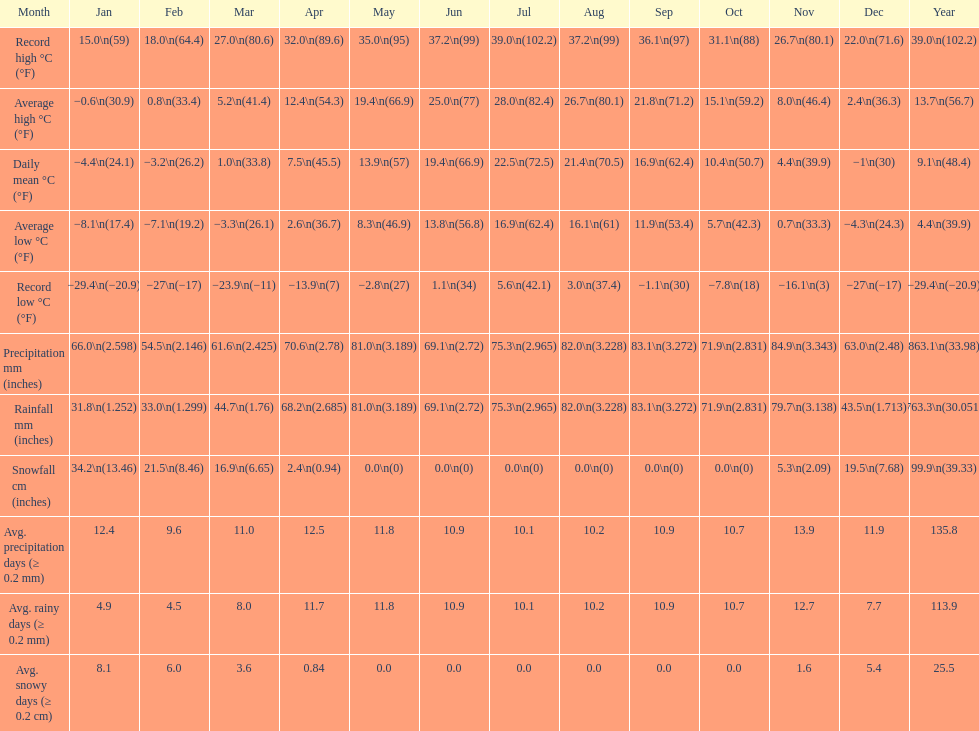Between january, october and december which month had the most rainfall? October. 